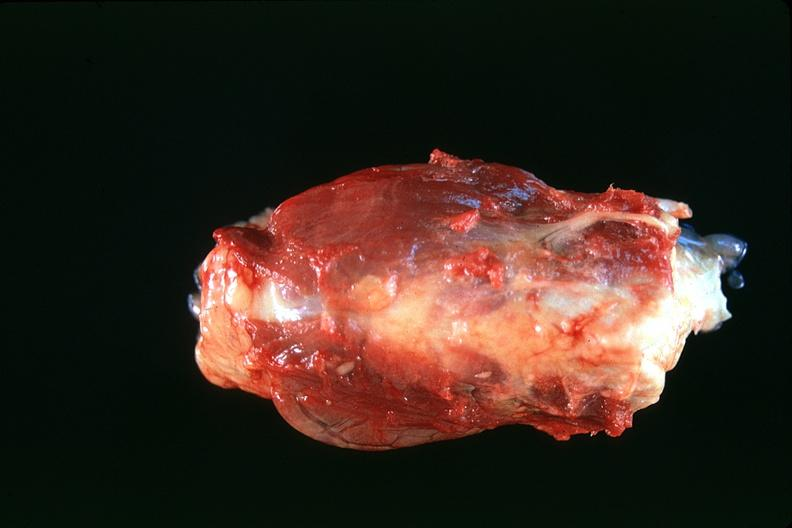s endocrine present?
Answer the question using a single word or phrase. Yes 